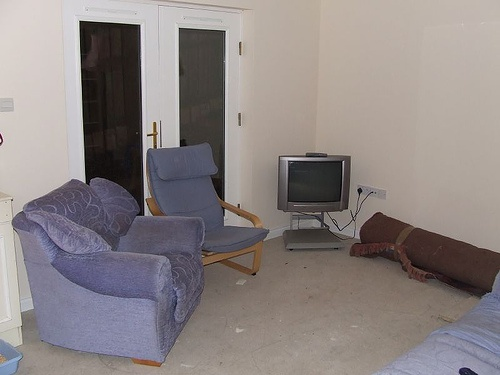Describe the objects in this image and their specific colors. I can see couch in lightgray and gray tones, chair in lightgray, gray, brown, and darkgray tones, couch in lightgray, darkgray, and gray tones, bed in lightgray and gray tones, and tv in lightgray, black, gray, and darkgray tones in this image. 